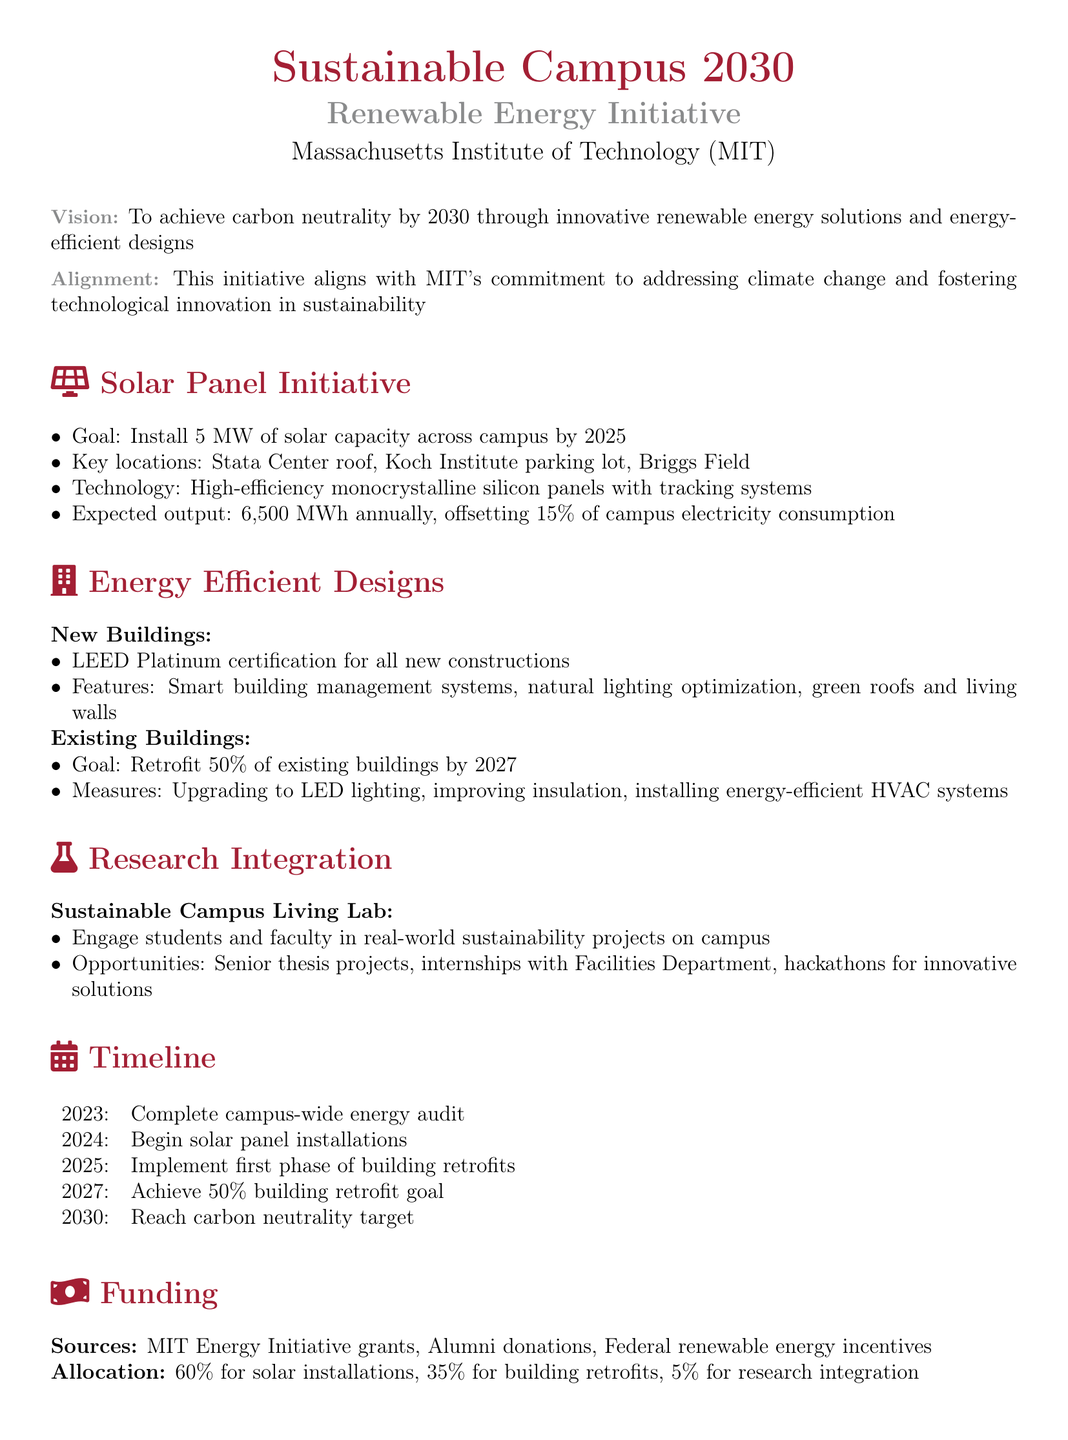What is the goal for solar capacity installation? The goal for solar capacity installation is 5 MW.
Answer: 5 MW What percentage of campus electricity consumption will the solar panels offset? The solar panels will offset 15% of campus electricity consumption.
Answer: 15% What is the target year for achieving carbon neutrality? The target year for achieving carbon neutrality is 2030.
Answer: 2030 How many existing buildings are planned to be retrofitted by 2027? The goal is to retrofit 50% of existing buildings by 2027.
Answer: 50% What type of panels will be installed in the solar initiative? The type of panels to be installed are high-efficiency monocrystalline silicon panels.
Answer: high-efficiency monocrystalline silicon panels What feature is included in all new constructions? All new constructions will have LEED Platinum certification.
Answer: LEED Platinum certification What percentage of funding is allocated for solar installations? 60% of funding is allocated for solar installations.
Answer: 60% When will the solar panel installations begin? The solar panel installations are scheduled to begin in 2024.
Answer: 2024 What is the purpose of the Sustainable Campus Living Lab? The purpose is to engage students and faculty in real-world sustainability projects on campus.
Answer: engage students and faculty in real-world sustainability projects 